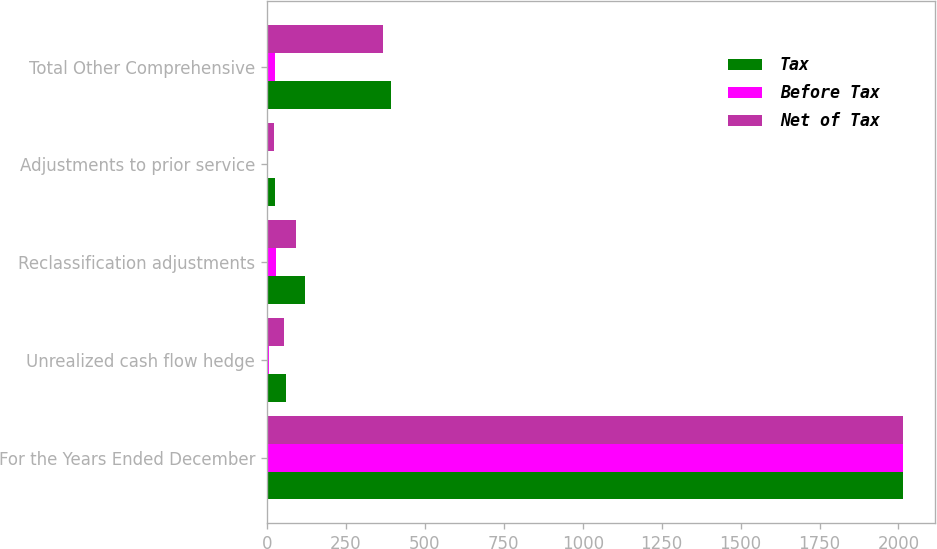Convert chart. <chart><loc_0><loc_0><loc_500><loc_500><stacked_bar_chart><ecel><fcel>For the Years Ended December<fcel>Unrealized cash flow hedge<fcel>Reclassification adjustments<fcel>Adjustments to prior service<fcel>Total Other Comprehensive<nl><fcel>Tax<fcel>2015<fcel>59.1<fcel>121<fcel>25<fcel>392.3<nl><fcel>Before Tax<fcel>2015<fcel>6.4<fcel>28<fcel>3.6<fcel>25.2<nl><fcel>Net of Tax<fcel>2015<fcel>52.7<fcel>93<fcel>21.4<fcel>367.1<nl></chart> 